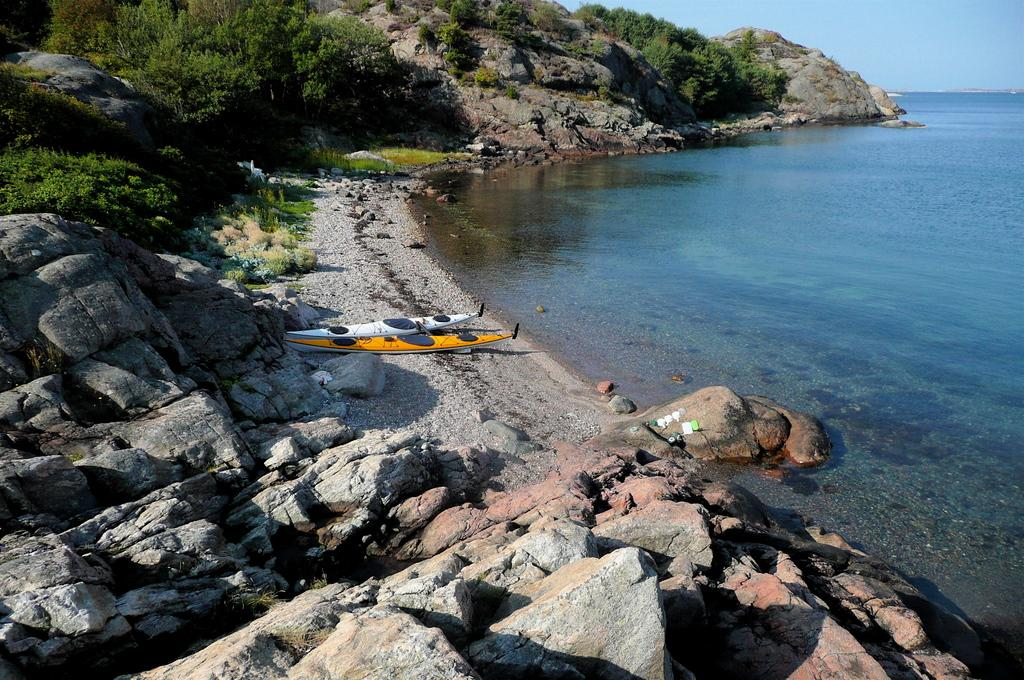What can be seen on the surface in the image? There are two boats on the surface in the image. What type of natural formation is visible in the image? There are rocks and a rock hill visible in the image. What type of vegetation is present in the image? There are trees in the image. What body of water is visible in the image? The sea is visible on the right side of the image. What part of the natural environment is visible in the image? The sky is visible in the image. What type of rice can be seen growing on the rock hill in the image? There is no rice present in the image; it features two boats, rocks, trees, a rock hill, the sea, and the sky. What is the purpose of the pail in the image? There is no pail present in the image. 